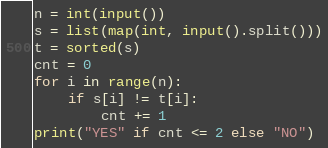<code> <loc_0><loc_0><loc_500><loc_500><_Python_>n = int(input())
s = list(map(int, input().split()))
t = sorted(s)
cnt = 0
for i in range(n):
    if s[i] != t[i]:
        cnt += 1
print("YES" if cnt <= 2 else "NO")
</code> 